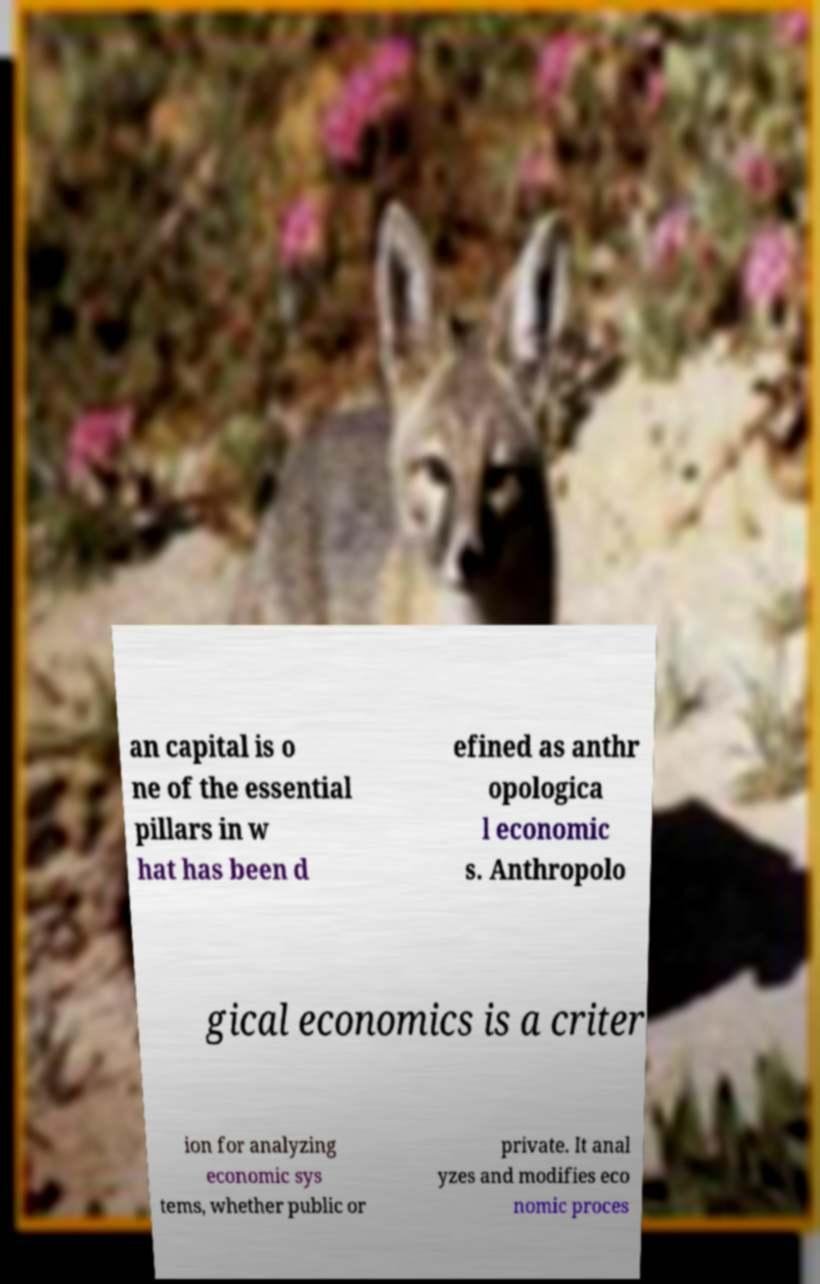For documentation purposes, I need the text within this image transcribed. Could you provide that? an capital is o ne of the essential pillars in w hat has been d efined as anthr opologica l economic s. Anthropolo gical economics is a criter ion for analyzing economic sys tems, whether public or private. It anal yzes and modifies eco nomic proces 